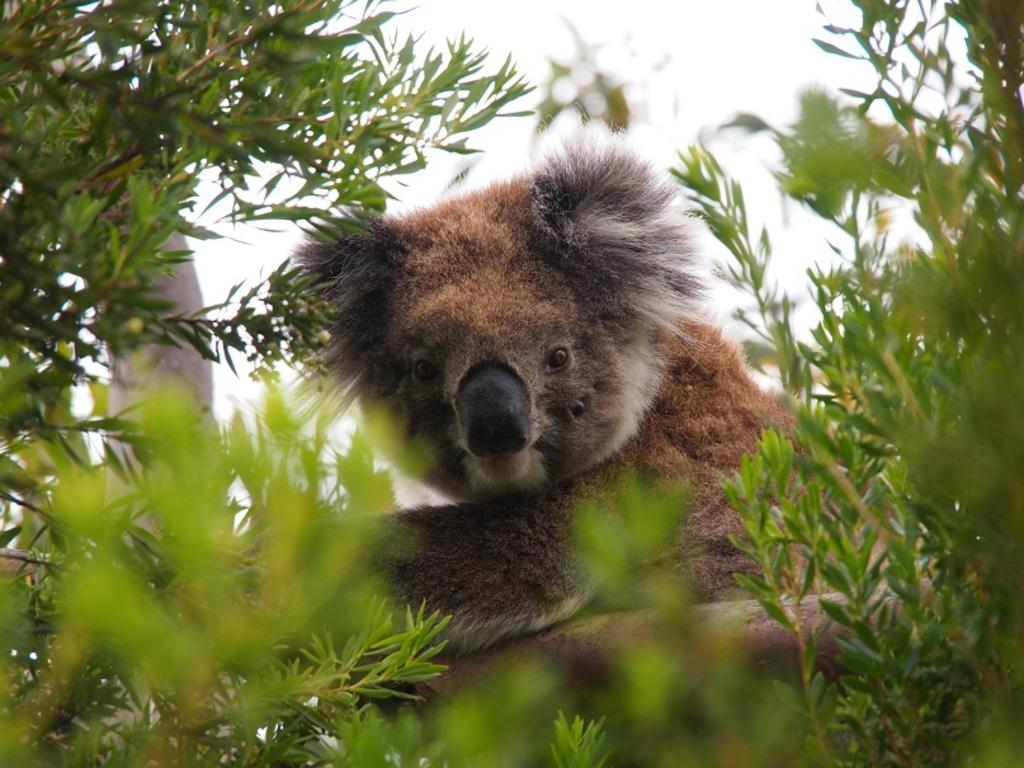What type of animal can be seen in the image? There is an animal in the image, but its specific type cannot be determined from the provided facts. Where is the animal located in the image? The animal is on a branch in the image. What can be seen in the background of the image? There are trees in the background of the image. What color is the cushion the animal is sitting on in the image? There is no cushion present in the image; the animal is on a branch. 